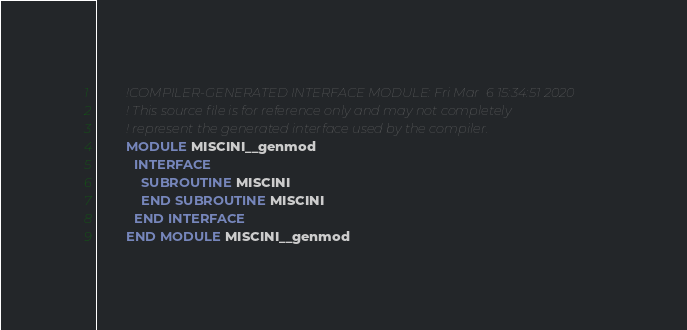Convert code to text. <code><loc_0><loc_0><loc_500><loc_500><_FORTRAN_>        !COMPILER-GENERATED INTERFACE MODULE: Fri Mar  6 15:34:51 2020
        ! This source file is for reference only and may not completely
        ! represent the generated interface used by the compiler.
        MODULE MISCINI__genmod
          INTERFACE 
            SUBROUTINE MISCINI
            END SUBROUTINE MISCINI
          END INTERFACE 
        END MODULE MISCINI__genmod
</code> 